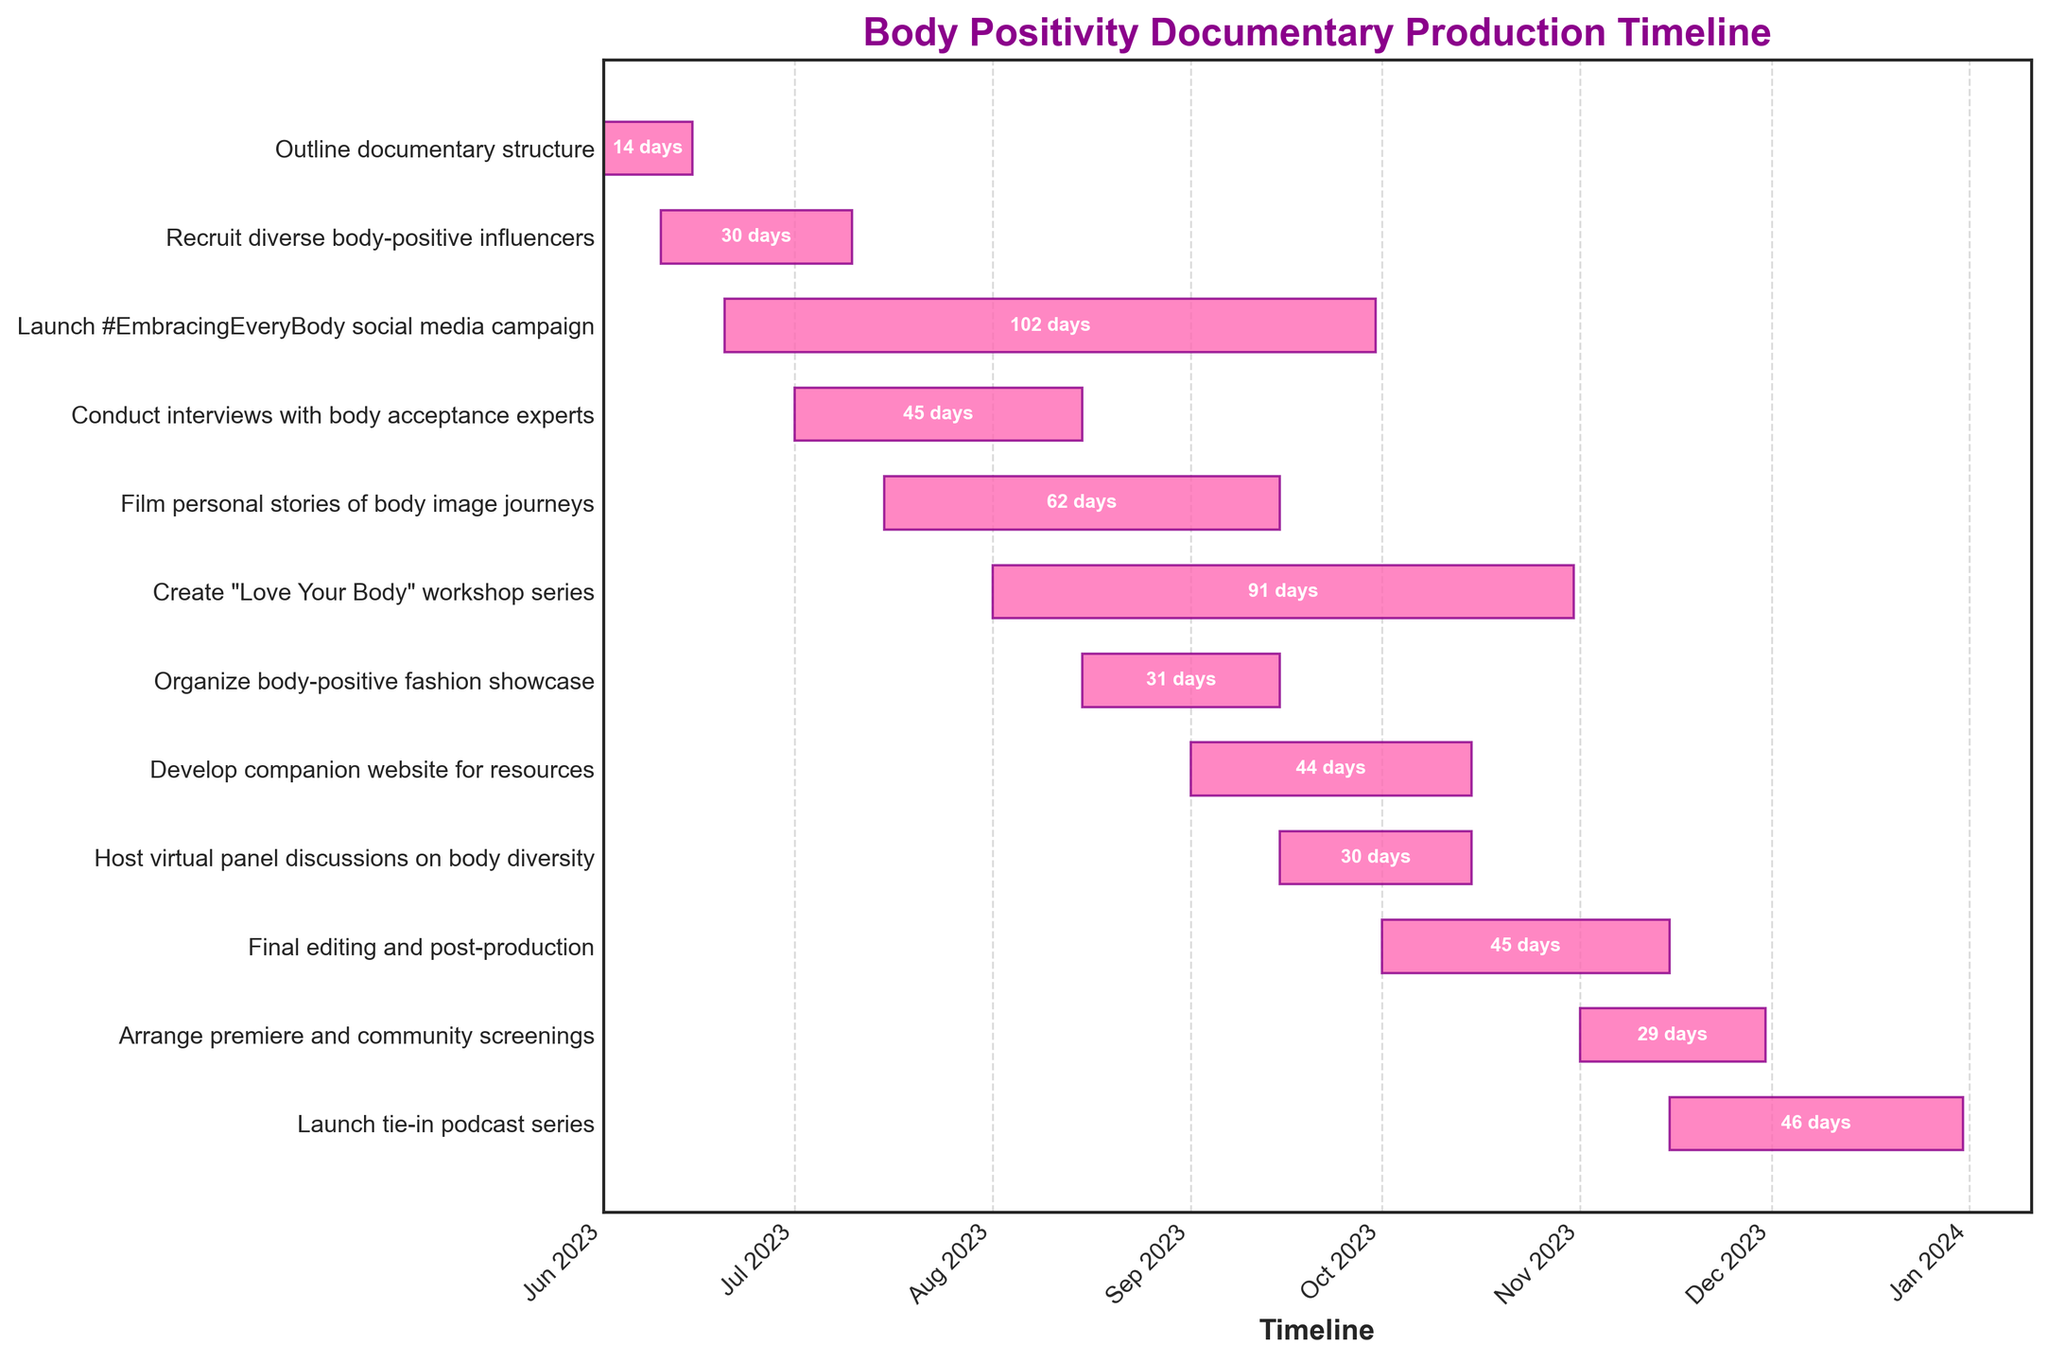What's the title of the figure? The title is usually located at the top of the figure. In this case, it reads "Body Positivity Documentary Production Timeline".
Answer: Body Positivity Documentary Production Timeline During which months does the "Launch #EmbracingEveryBody social media campaign" activity occur? To answer this, look at the start and end dates of this task on the horizontal bar. The "Launch #EmbracingEveryBody social media campaign" starts on June 20, 2023, and ends on September 30, 2023.
Answer: June to September 2023 Which task has the longest duration and what is its duration? By comparing the length of each horizontal bar, the "Create 'Love Your Body' workshop series" task is the longest. Check the dates: it starts on August 1, 2023, and ends on October 31, 2023, giving a total of approximately 92 days (August 1–31, September 1-30, October 1-31).
Answer: Create "Love Your Body" workshop series, 92 days What are the overlapping tasks in August 2023? To find overlapping tasks, check which tasks have durations spanning through August. These tasks are "Conduct interviews with body acceptance experts", "Film personal stories of body image journeys", "Create 'Love Your Body' workshop series", and "Organize body-positive fashion showcase".
Answer: Conduct interviews with body acceptance experts, Film personal stories of body image journeys, Create "Love Your Body" workshop series, and Organize body-positive fashion showcase Which task ends first, "Outline documentary structure" or "Recruit diverse body-positive influencers"? Look at the end dates of both tasks. "Outline documentary structure" ends on June 15, 2023, whereas "Recruit diverse body-positive influencers" ends on July 10, 2023.
Answer: Outline documentary structure What task directly follows "Develop companion website for resources"? Look at the tasks by end dates. "Develop companion website for resources" ends on October 15, 2023. The task that starts immediately after is "Host virtual panel discussions on body diversity" which also starts on September 15, 2023. Thus, it overlaps and continues immediately after.
Answer: Host virtual panel discussions on body diversity Calculate the total duration from the start of "Outline documentary structure" to the end of "Final editing and post-production". "Outline documentary structure" starts on June 1, 2023, and "Final editing and post-production" ends on November 15, 2023. The total duration is from June 1 to November 15, which is about 168 days.
Answer: 168 days Which tasks are completed by September 2023? Tasks that end on or before September 30, 2023, include "Outline documentary structure", "Recruit diverse body-positive influencers", "Conduct interviews with body acceptance experts", "Film personal stories of body image journeys", "Organize body-positive fashion showcase", and "Launch #EmbracingEveryBody social media campaign".
Answer: Outline documentary structure, Recruit diverse body-positive influencers, Conduct interviews with body acceptance experts, Film personal stories of body image journeys, Organize body-positive fashion showcase, Launch #EmbracingEveryBody social media campaign Does "Arrange premiere and community screenings" overlap with "Launch tie-in podcast series"? To check for overlapping tasks, look at their start and end dates. "Arrange premiere and community screenings" is from November 1 to November 30, 2023, and "Launch tie-in podcast series" starts on November 15 and ends on December 31, 2023. They overlap from November 15 to November 30.
Answer: Yes 